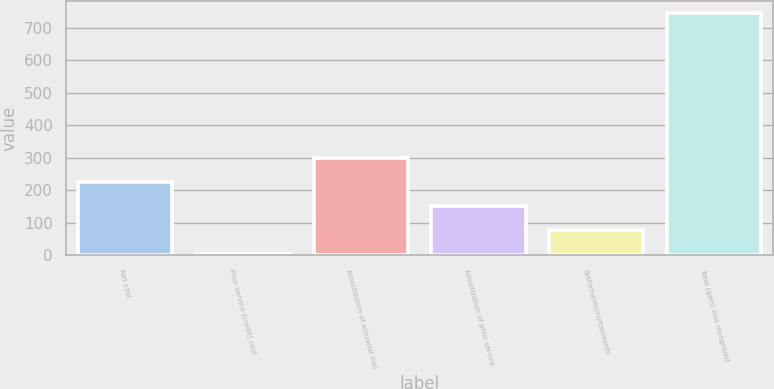<chart> <loc_0><loc_0><loc_500><loc_500><bar_chart><fcel>Net cost<fcel>Prior service (credit) cost<fcel>Amortization of actuarial loss<fcel>Amortization of prior service<fcel>Settlements/curtailments<fcel>Total (gain) loss recognized<nl><fcel>227<fcel>5<fcel>301<fcel>153<fcel>79<fcel>745<nl></chart> 